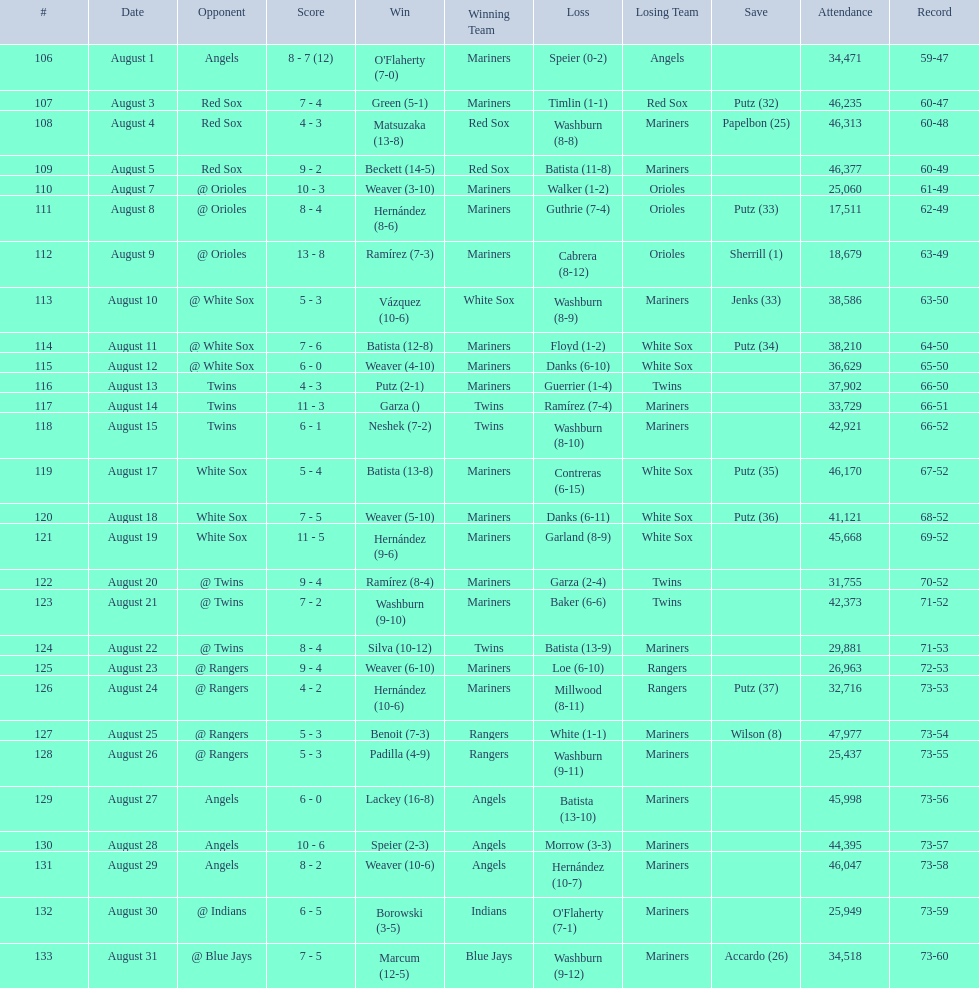Games above 30,000 in attendance 21. 